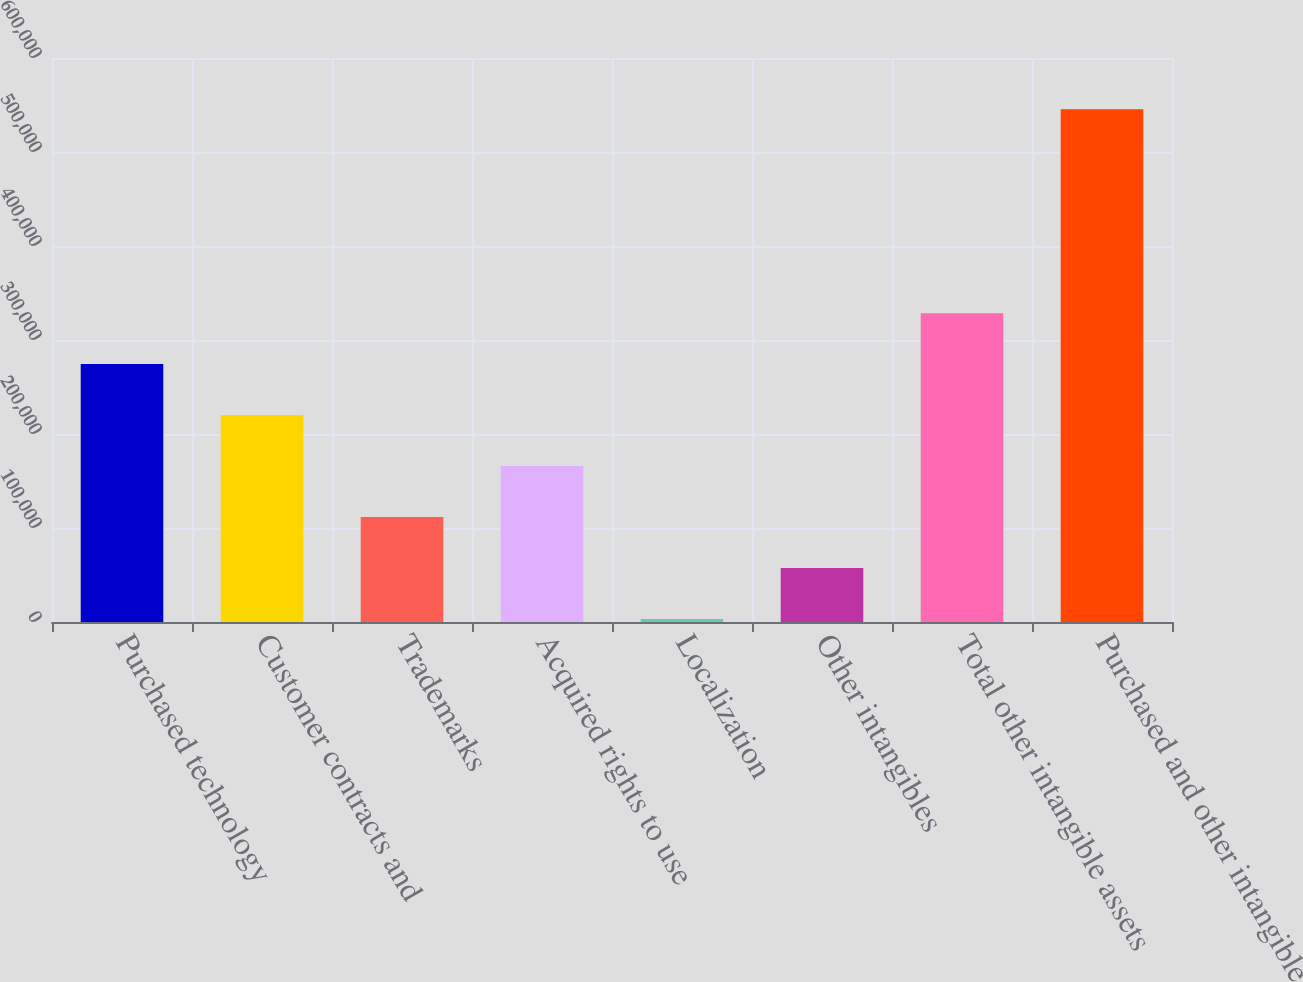Convert chart to OTSL. <chart><loc_0><loc_0><loc_500><loc_500><bar_chart><fcel>Purchased technology<fcel>Customer contracts and<fcel>Trademarks<fcel>Acquired rights to use<fcel>Localization<fcel>Other intangibles<fcel>Total other intangible assets<fcel>Purchased and other intangible<nl><fcel>274348<fcel>220113<fcel>111642<fcel>165878<fcel>3171<fcel>57406.5<fcel>328584<fcel>545526<nl></chart> 